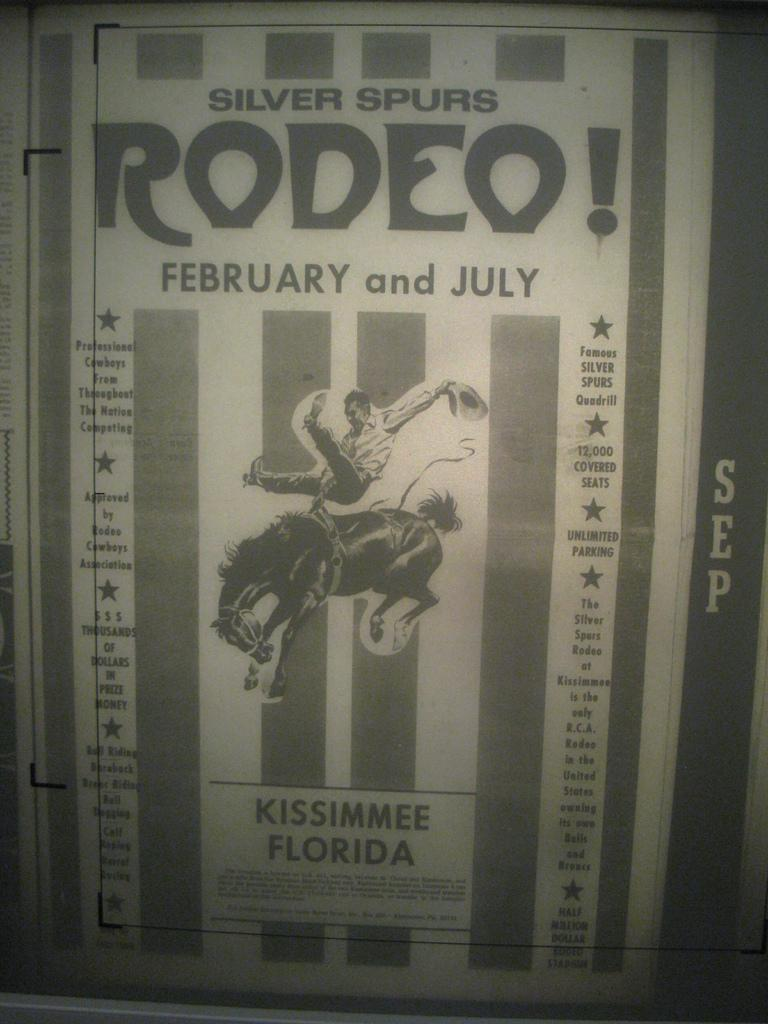<image>
Render a clear and concise summary of the photo. A sign that reads SILVER SPURS RODEO! FEBRUARY and JULY. 